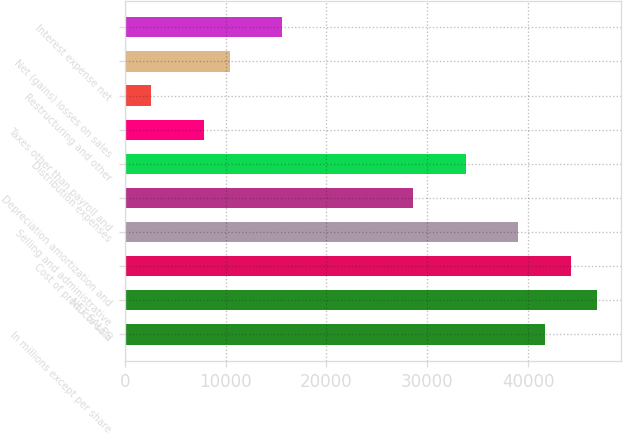<chart> <loc_0><loc_0><loc_500><loc_500><bar_chart><fcel>In millions except per share<fcel>NET SALES<fcel>Cost of products sold<fcel>Selling and administrative<fcel>Depreciation amortization and<fcel>Distribution expenses<fcel>Taxes other than payroll and<fcel>Restructuring and other<fcel>Net (gains) losses on sales<fcel>Interest expense net<nl><fcel>41646<fcel>46850<fcel>44248<fcel>39044<fcel>28636<fcel>33840<fcel>7820<fcel>2616<fcel>10422<fcel>15626<nl></chart> 